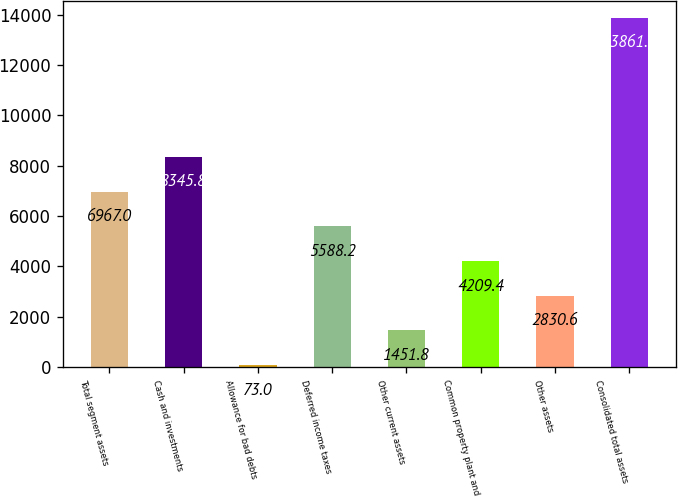Convert chart to OTSL. <chart><loc_0><loc_0><loc_500><loc_500><bar_chart><fcel>Total segment assets<fcel>Cash and investments<fcel>Allowance for bad debts<fcel>Deferred income taxes<fcel>Other current assets<fcel>Common property plant and<fcel>Other assets<fcel>Consolidated total assets<nl><fcel>6967<fcel>8345.8<fcel>73<fcel>5588.2<fcel>1451.8<fcel>4209.4<fcel>2830.6<fcel>13861<nl></chart> 